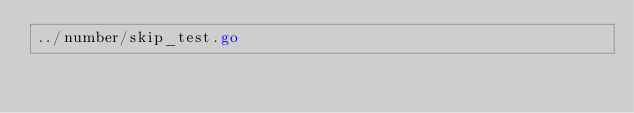Convert code to text. <code><loc_0><loc_0><loc_500><loc_500><_Go_>../number/skip_test.go</code> 